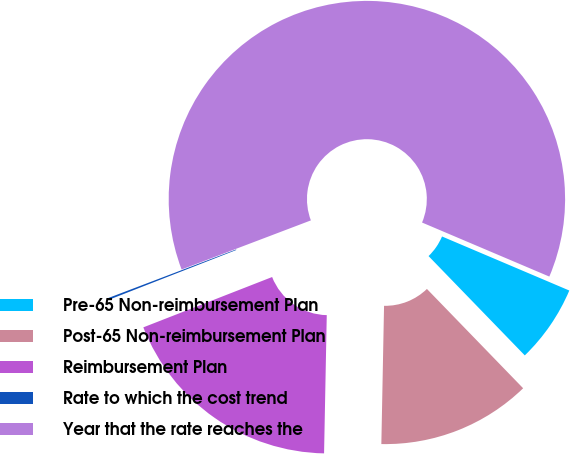<chart> <loc_0><loc_0><loc_500><loc_500><pie_chart><fcel>Pre-65 Non-reimbursement Plan<fcel>Post-65 Non-reimbursement Plan<fcel>Reimbursement Plan<fcel>Rate to which the cost trend<fcel>Year that the rate reaches the<nl><fcel>6.36%<fcel>12.56%<fcel>18.76%<fcel>0.15%<fcel>62.17%<nl></chart> 